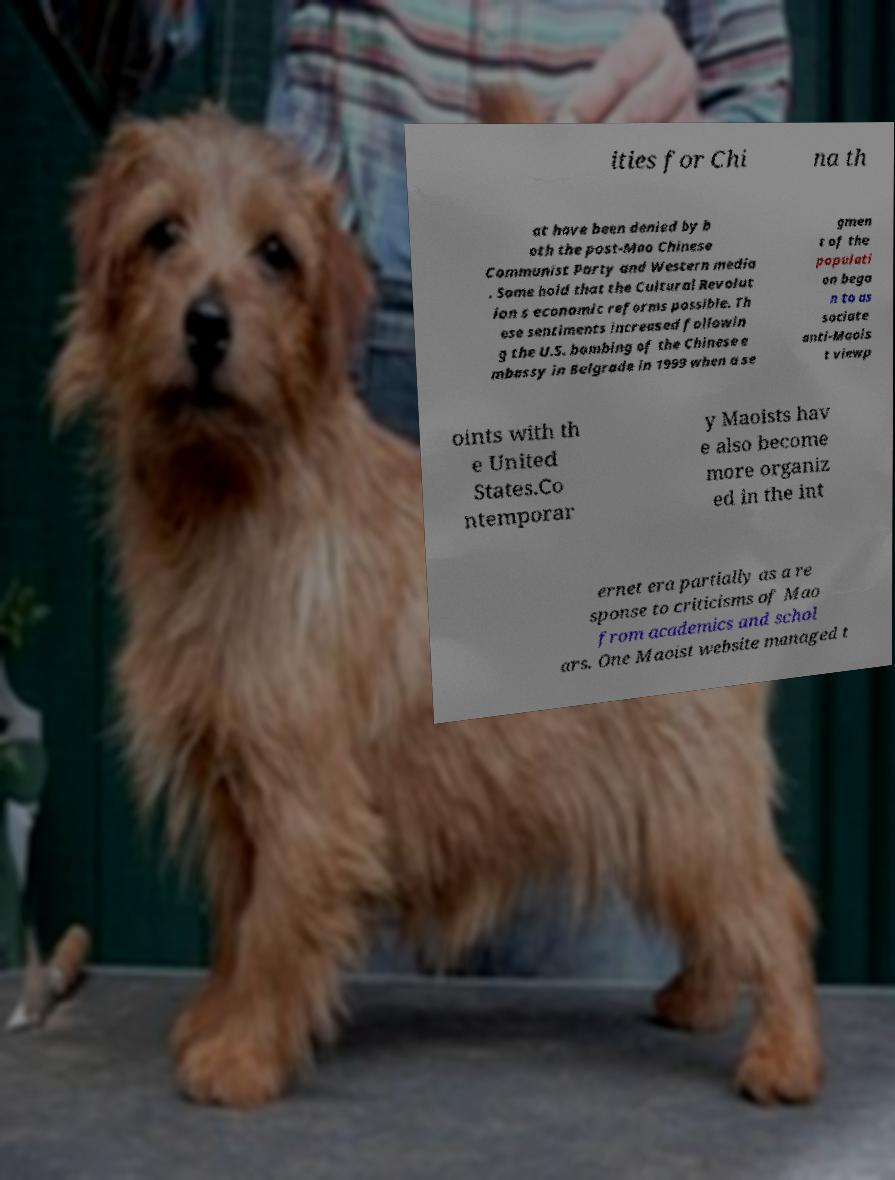Could you assist in decoding the text presented in this image and type it out clearly? ities for Chi na th at have been denied by b oth the post-Mao Chinese Communist Party and Western media . Some hold that the Cultural Revolut ion s economic reforms possible. Th ese sentiments increased followin g the U.S. bombing of the Chinese e mbassy in Belgrade in 1999 when a se gmen t of the populati on bega n to as sociate anti-Maois t viewp oints with th e United States.Co ntemporar y Maoists hav e also become more organiz ed in the int ernet era partially as a re sponse to criticisms of Mao from academics and schol ars. One Maoist website managed t 